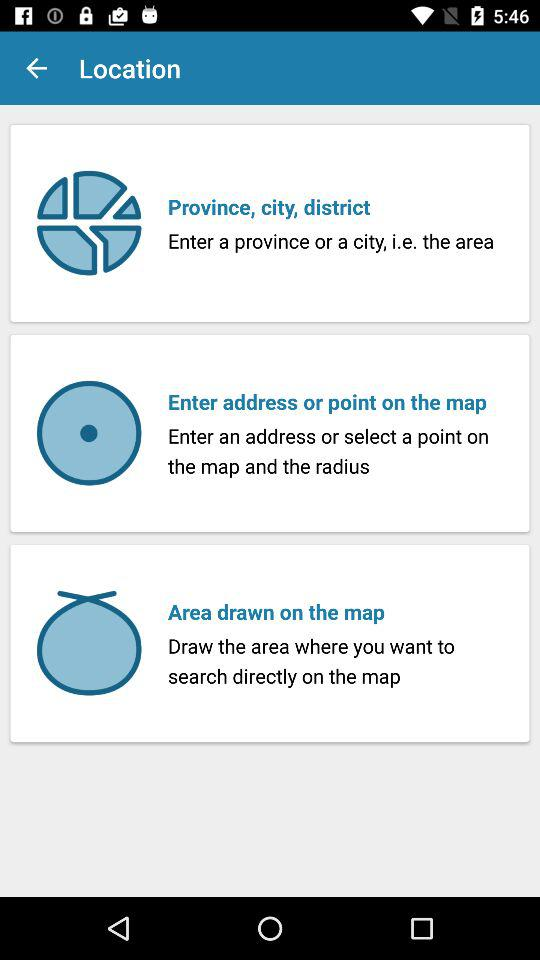How many options are there to choose a search location?
Answer the question using a single word or phrase. 3 